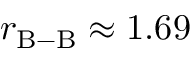Convert formula to latex. <formula><loc_0><loc_0><loc_500><loc_500>r _ { B - B } \approx 1 . 6 9</formula> 